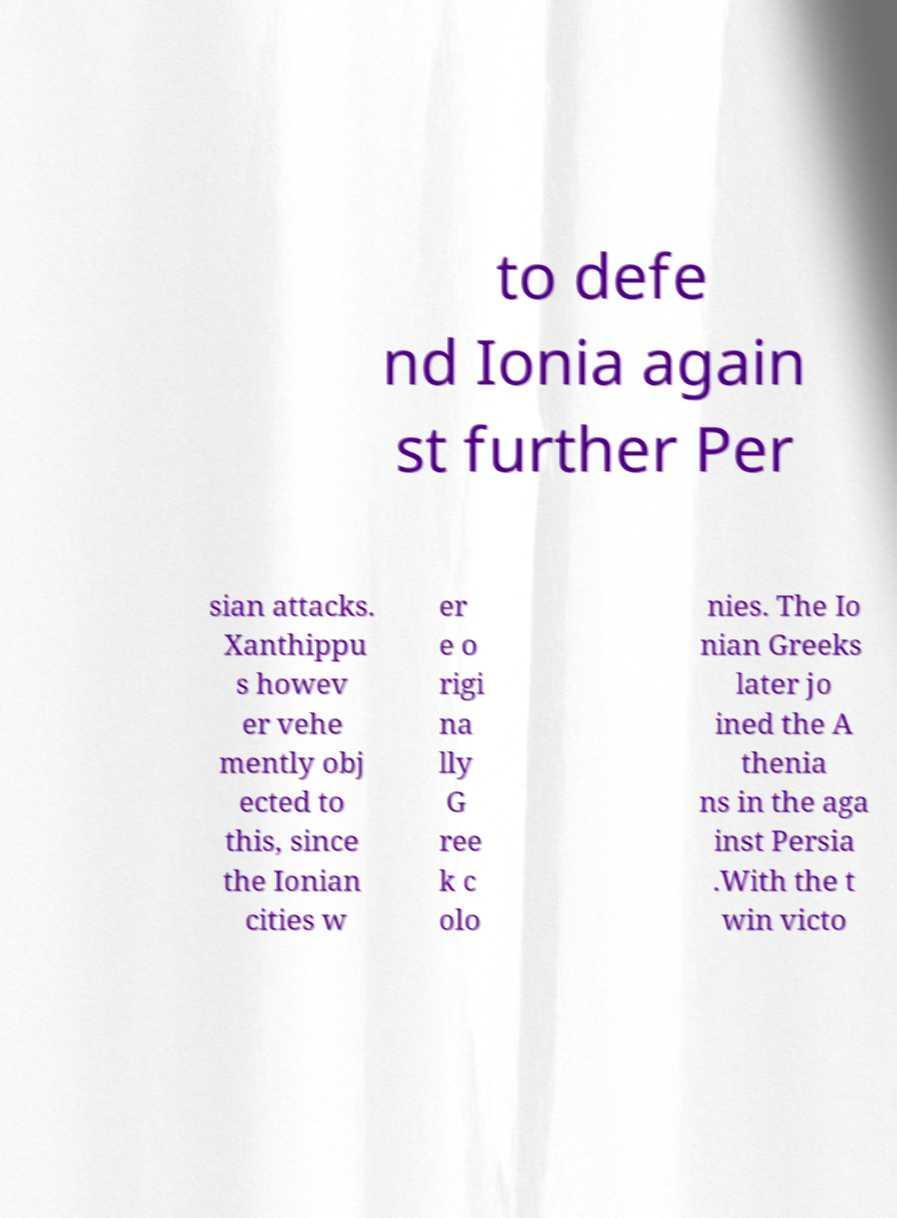For documentation purposes, I need the text within this image transcribed. Could you provide that? to defe nd Ionia again st further Per sian attacks. Xanthippu s howev er vehe mently obj ected to this, since the Ionian cities w er e o rigi na lly G ree k c olo nies. The Io nian Greeks later jo ined the A thenia ns in the aga inst Persia .With the t win victo 